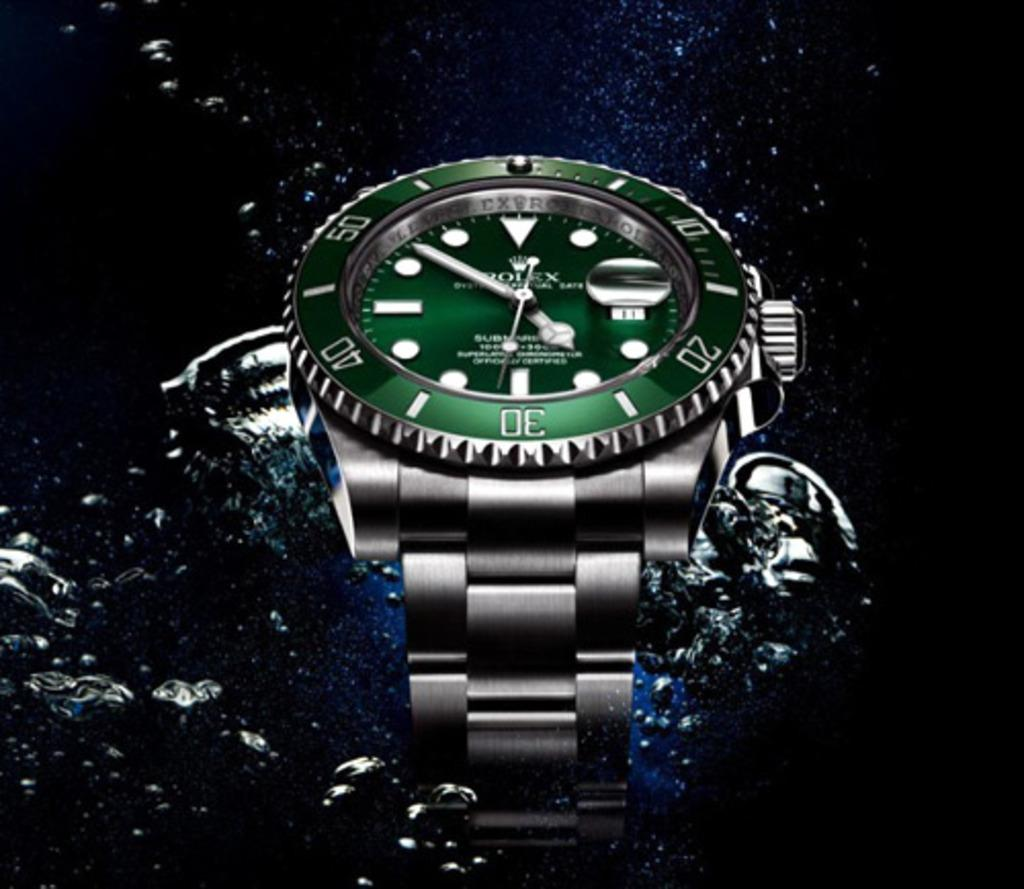Provide a one-sentence caption for the provided image. A Rolex watch with a green face is photographed in water. 